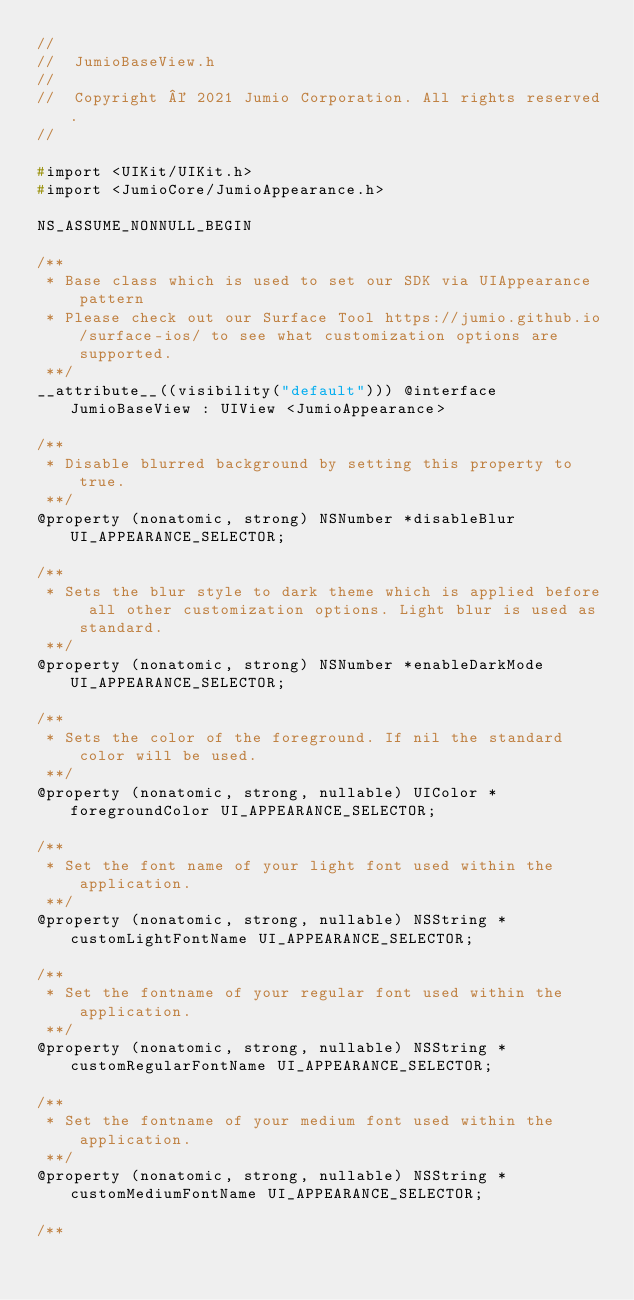Convert code to text. <code><loc_0><loc_0><loc_500><loc_500><_C_>//
//  JumioBaseView.h
//
//  Copyright © 2021 Jumio Corporation. All rights reserved.
//

#import <UIKit/UIKit.h>
#import <JumioCore/JumioAppearance.h>

NS_ASSUME_NONNULL_BEGIN

/**
 * Base class which is used to set our SDK via UIAppearance pattern
 * Please check out our Surface Tool https://jumio.github.io/surface-ios/ to see what customization options are supported.
 **/
__attribute__((visibility("default"))) @interface JumioBaseView : UIView <JumioAppearance>

/**
 * Disable blurred background by setting this property to true.
 **/
@property (nonatomic, strong) NSNumber *disableBlur UI_APPEARANCE_SELECTOR;

/**
 * Sets the blur style to dark theme which is applied before all other customization options. Light blur is used as standard.
 **/
@property (nonatomic, strong) NSNumber *enableDarkMode UI_APPEARANCE_SELECTOR;

/**
 * Sets the color of the foreground. If nil the standard color will be used.
 **/
@property (nonatomic, strong, nullable) UIColor *foregroundColor UI_APPEARANCE_SELECTOR;

/**
 * Set the font name of your light font used within the application.
 **/
@property (nonatomic, strong, nullable) NSString *customLightFontName UI_APPEARANCE_SELECTOR;

/**
 * Set the fontname of your regular font used within the application.
 **/
@property (nonatomic, strong, nullable) NSString *customRegularFontName UI_APPEARANCE_SELECTOR;

/**
 * Set the fontname of your medium font used within the application.
 **/
@property (nonatomic, strong, nullable) NSString *customMediumFontName UI_APPEARANCE_SELECTOR;

/**</code> 